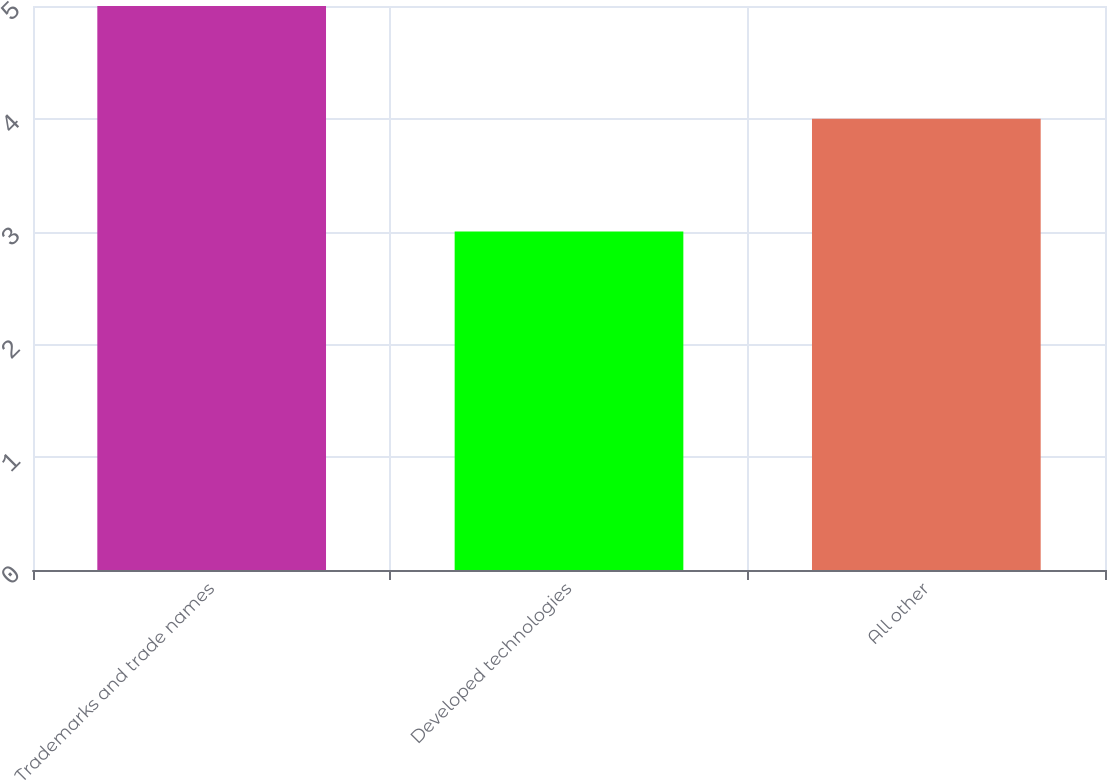Convert chart to OTSL. <chart><loc_0><loc_0><loc_500><loc_500><bar_chart><fcel>Trademarks and trade names<fcel>Developed technologies<fcel>All other<nl><fcel>5<fcel>3<fcel>4<nl></chart> 